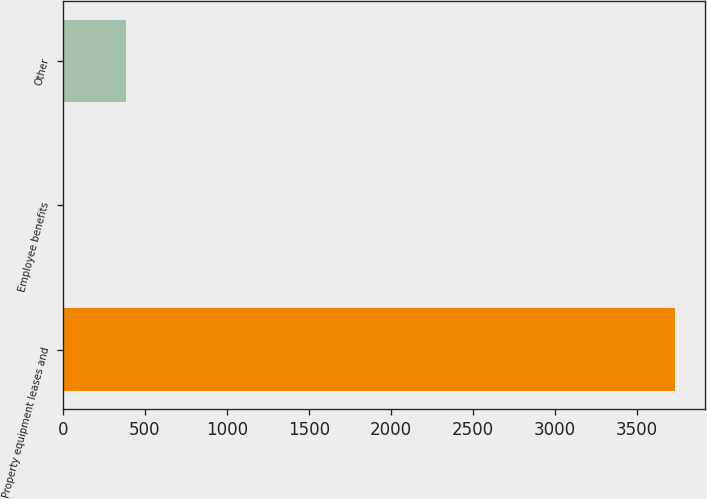<chart> <loc_0><loc_0><loc_500><loc_500><bar_chart><fcel>Property equipment leases and<fcel>Employee benefits<fcel>Other<nl><fcel>3730<fcel>11<fcel>382.9<nl></chart> 